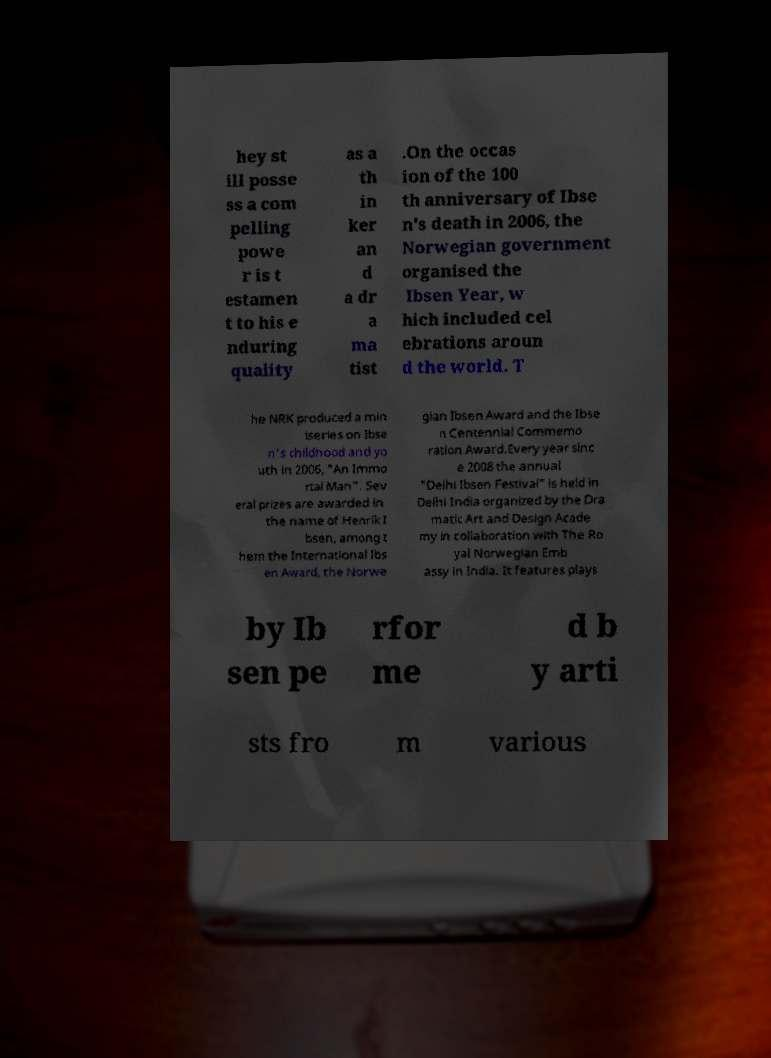There's text embedded in this image that I need extracted. Can you transcribe it verbatim? hey st ill posse ss a com pelling powe r is t estamen t to his e nduring quality as a th in ker an d a dr a ma tist .On the occas ion of the 100 th anniversary of Ibse n's death in 2006, the Norwegian government organised the Ibsen Year, w hich included cel ebrations aroun d the world. T he NRK produced a min iseries on Ibse n's childhood and yo uth in 2006, "An Immo rtal Man". Sev eral prizes are awarded in the name of Henrik I bsen, among t hem the International Ibs en Award, the Norwe gian Ibsen Award and the Ibse n Centennial Commemo ration Award.Every year sinc e 2008 the annual "Delhi Ibsen Festival" is held in Delhi India organized by the Dra matic Art and Design Acade my in collaboration with The Ro yal Norwegian Emb assy in India. It features plays by Ib sen pe rfor me d b y arti sts fro m various 